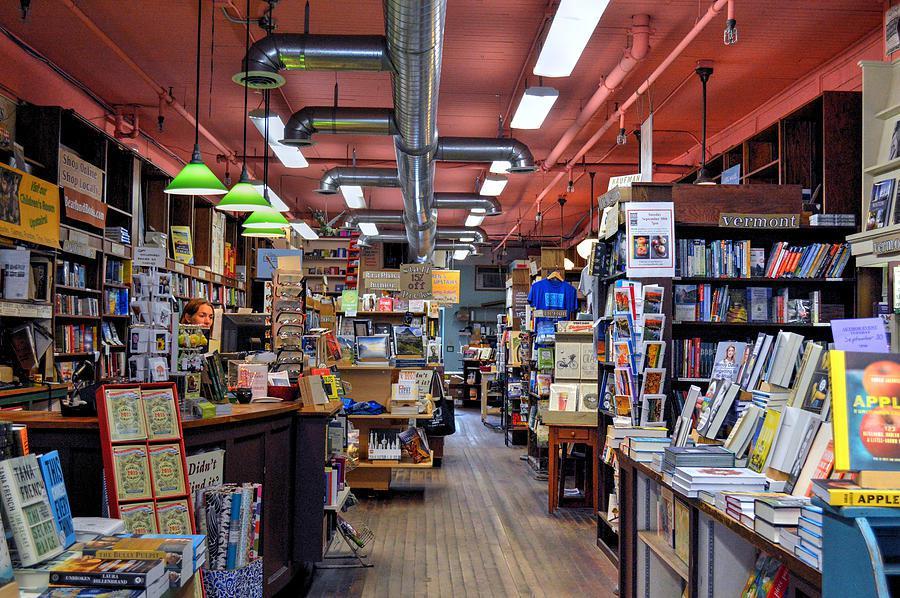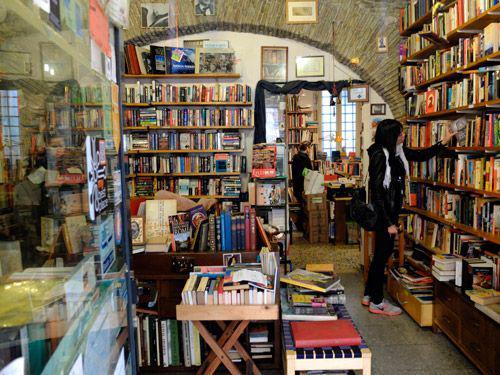The first image is the image on the left, the second image is the image on the right. Given the left and right images, does the statement "In one image, a long gray pipe runs the length of the bookstore ceiling." hold true? Answer yes or no. Yes. The first image is the image on the left, the second image is the image on the right. Given the left and right images, does the statement "One person is browsing at the bookshelf on the right side." hold true? Answer yes or no. Yes. 